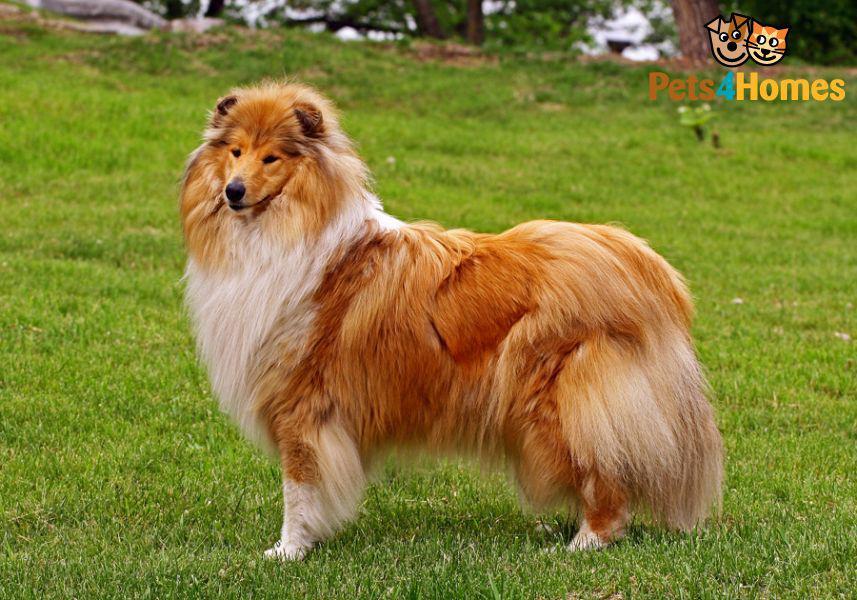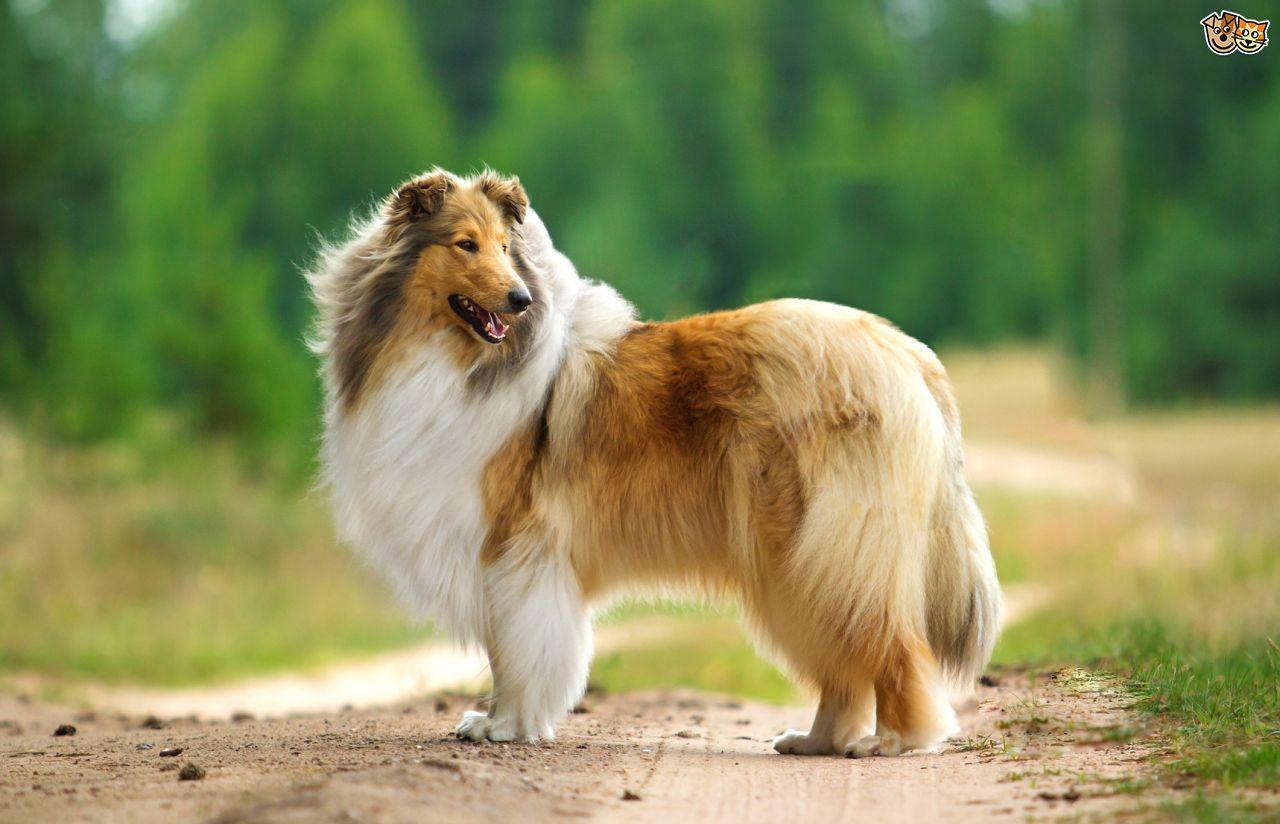The first image is the image on the left, the second image is the image on the right. Analyze the images presented: Is the assertion "The dog in the image on the right is moving toward the camera" valid? Answer yes or no. No. 